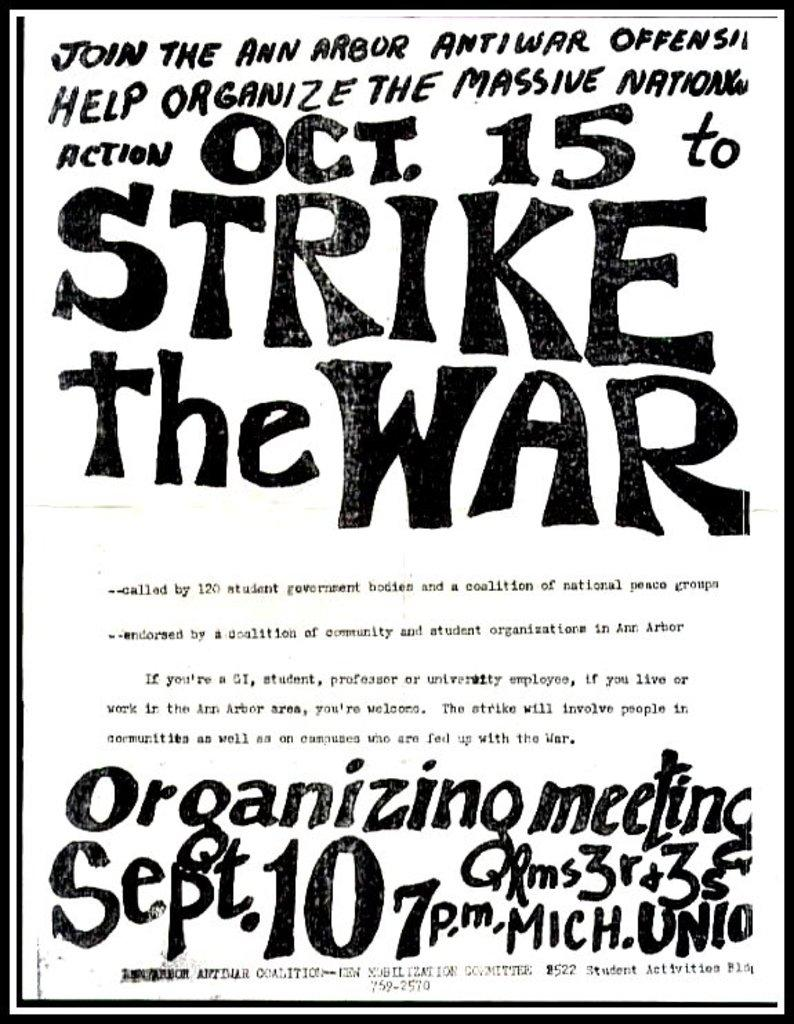<image>
Create a compact narrative representing the image presented. Vintage hand designed anti war poster for October 15 to Strike the War meeting. 